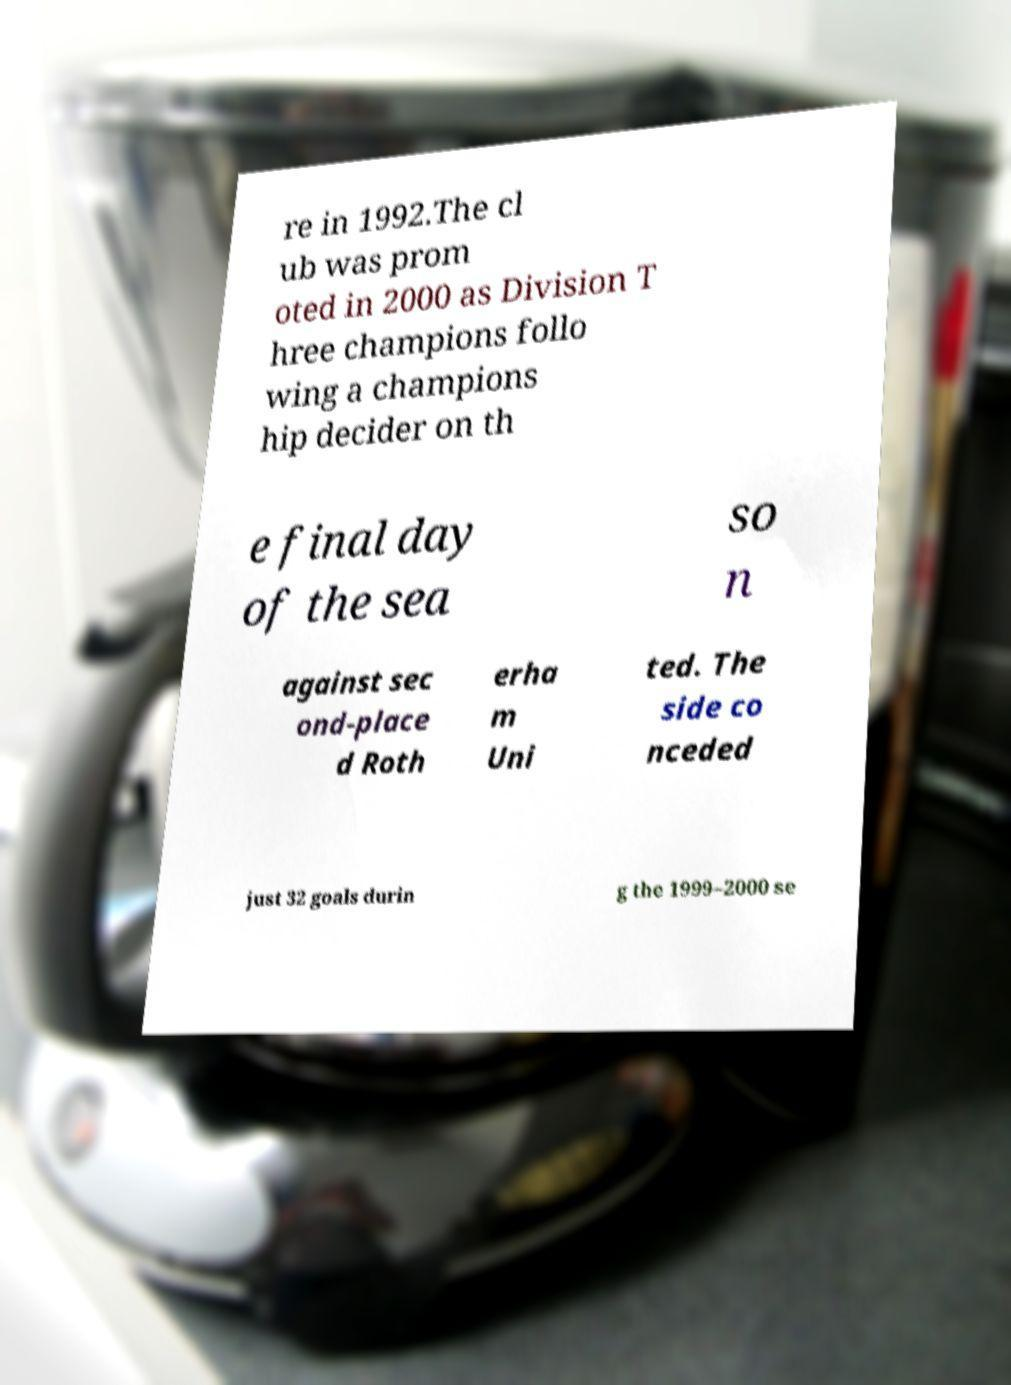There's text embedded in this image that I need extracted. Can you transcribe it verbatim? re in 1992.The cl ub was prom oted in 2000 as Division T hree champions follo wing a champions hip decider on th e final day of the sea so n against sec ond-place d Roth erha m Uni ted. The side co nceded just 32 goals durin g the 1999–2000 se 